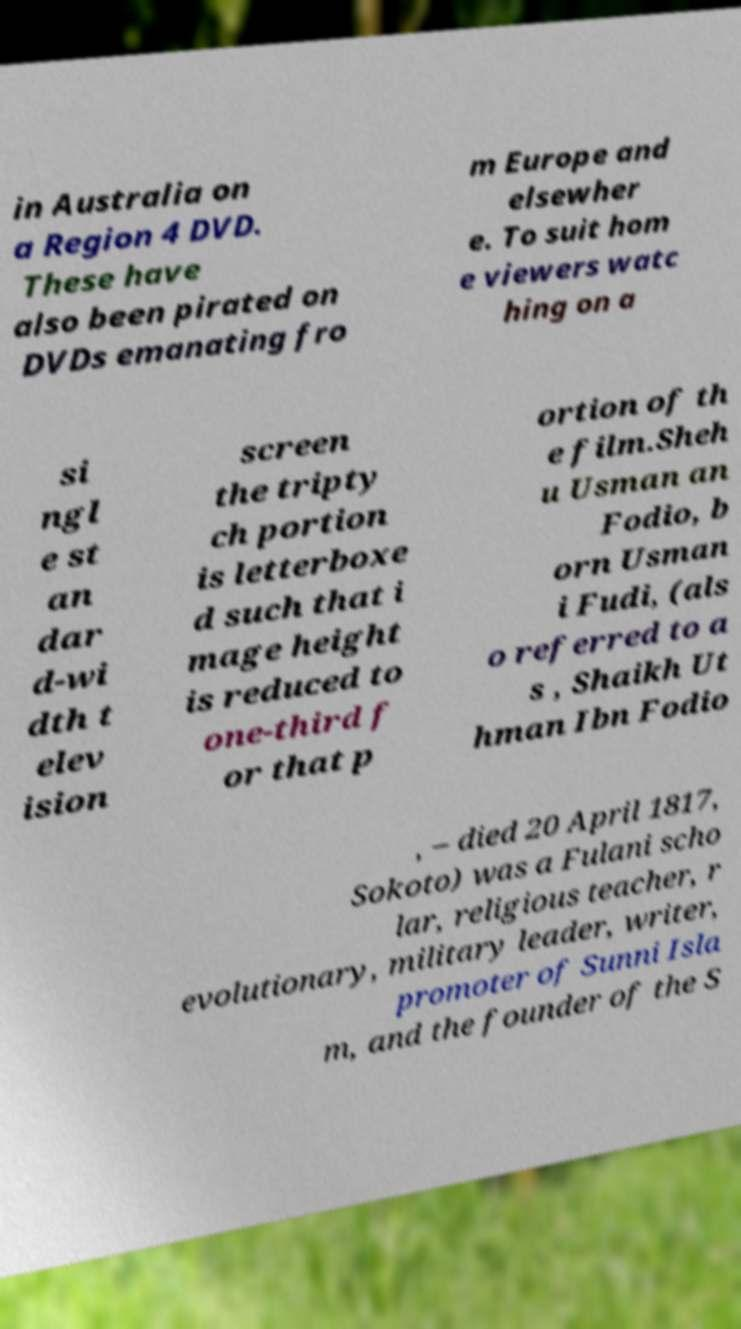Could you extract and type out the text from this image? in Australia on a Region 4 DVD. These have also been pirated on DVDs emanating fro m Europe and elsewher e. To suit hom e viewers watc hing on a si ngl e st an dar d-wi dth t elev ision screen the tripty ch portion is letterboxe d such that i mage height is reduced to one-third f or that p ortion of th e film.Sheh u Usman an Fodio, b orn Usman i Fudi, (als o referred to a s , Shaikh Ut hman Ibn Fodio , – died 20 April 1817, Sokoto) was a Fulani scho lar, religious teacher, r evolutionary, military leader, writer, promoter of Sunni Isla m, and the founder of the S 